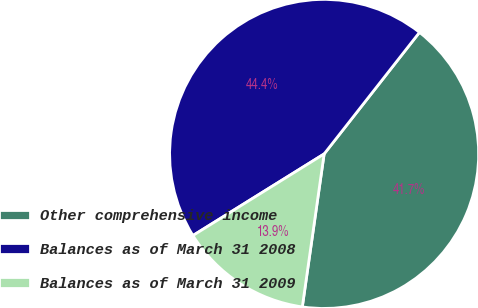<chart> <loc_0><loc_0><loc_500><loc_500><pie_chart><fcel>Other comprehensive income<fcel>Balances as of March 31 2008<fcel>Balances as of March 31 2009<nl><fcel>41.67%<fcel>44.44%<fcel>13.89%<nl></chart> 